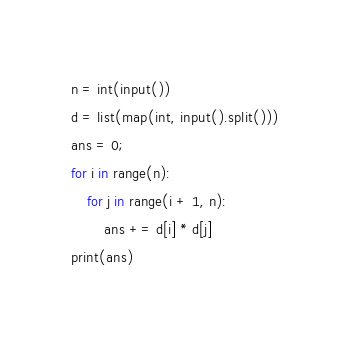<code> <loc_0><loc_0><loc_500><loc_500><_Python_>n = int(input())
d = list(map(int, input().split()))
ans = 0;
for i in range(n):
    for j in range(i + 1, n):
        ans += d[i] * d[j]
print(ans)
</code> 